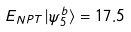<formula> <loc_0><loc_0><loc_500><loc_500>E _ { N P T } | \psi _ { 5 } ^ { b } \rangle = 1 7 . 5</formula> 